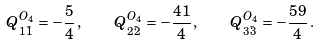Convert formula to latex. <formula><loc_0><loc_0><loc_500><loc_500>Q ^ { O _ { 4 } } _ { 1 \bar { 1 } } = - \frac { 5 } { 4 } \, , \quad Q ^ { O _ { 4 } } _ { 2 \bar { 2 } } = - \frac { 4 1 } { 4 } \, , \quad Q ^ { O _ { 4 } } _ { 3 \bar { 3 } } = - \frac { 5 9 } { 4 } \, .</formula> 